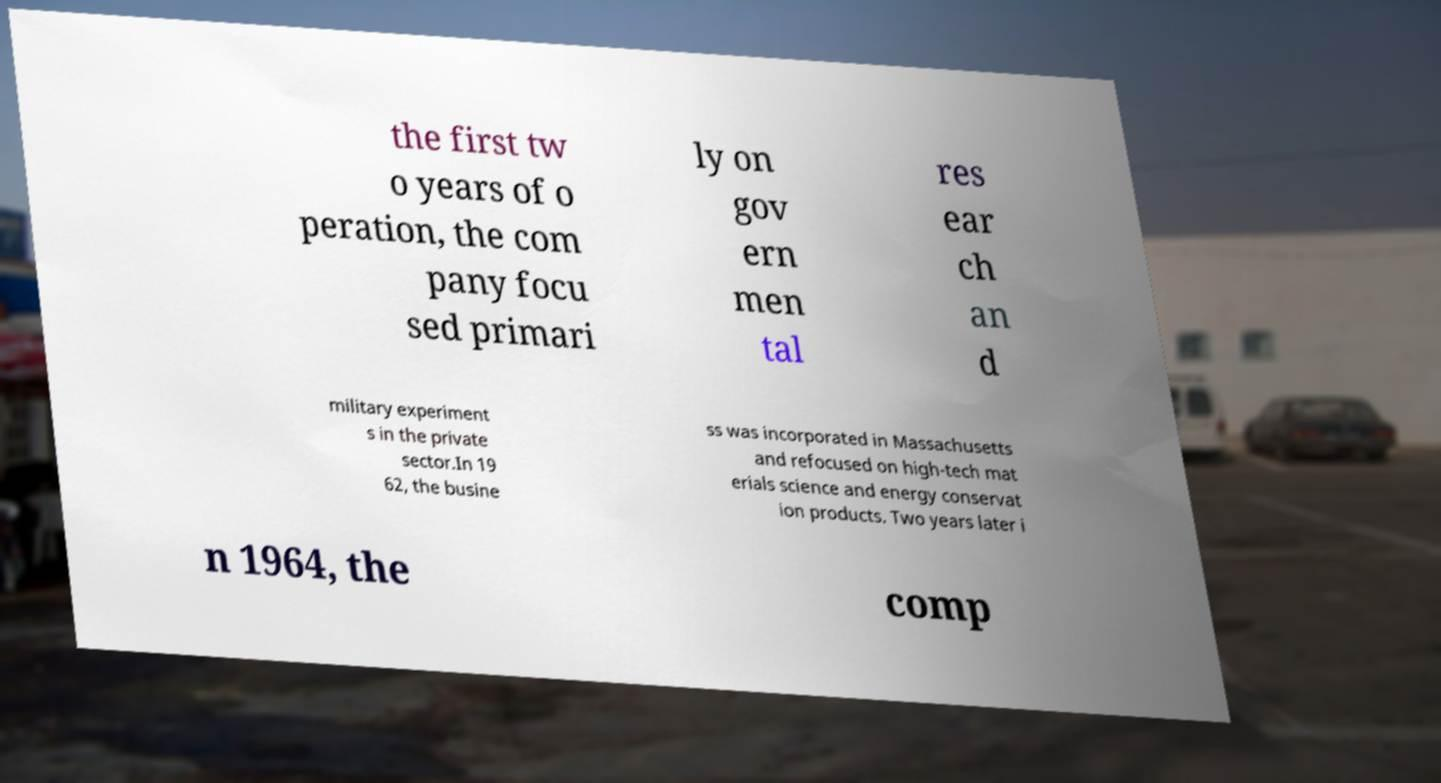There's text embedded in this image that I need extracted. Can you transcribe it verbatim? the first tw o years of o peration, the com pany focu sed primari ly on gov ern men tal res ear ch an d military experiment s in the private sector.In 19 62, the busine ss was incorporated in Massachusetts and refocused on high-tech mat erials science and energy conservat ion products. Two years later i n 1964, the comp 